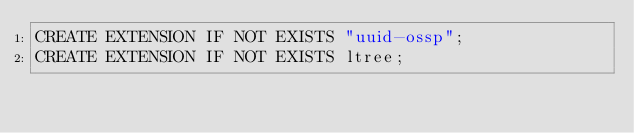<code> <loc_0><loc_0><loc_500><loc_500><_SQL_>CREATE EXTENSION IF NOT EXISTS "uuid-ossp";
CREATE EXTENSION IF NOT EXISTS ltree;
</code> 